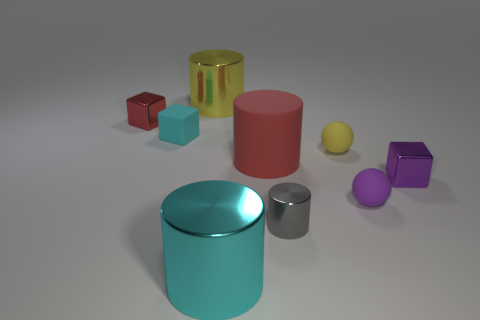Subtract all cubes. How many objects are left? 6 Add 4 tiny brown blocks. How many tiny brown blocks exist? 4 Subtract 0 yellow cubes. How many objects are left? 9 Subtract all cyan matte cylinders. Subtract all purple spheres. How many objects are left? 8 Add 7 small purple metal objects. How many small purple metal objects are left? 8 